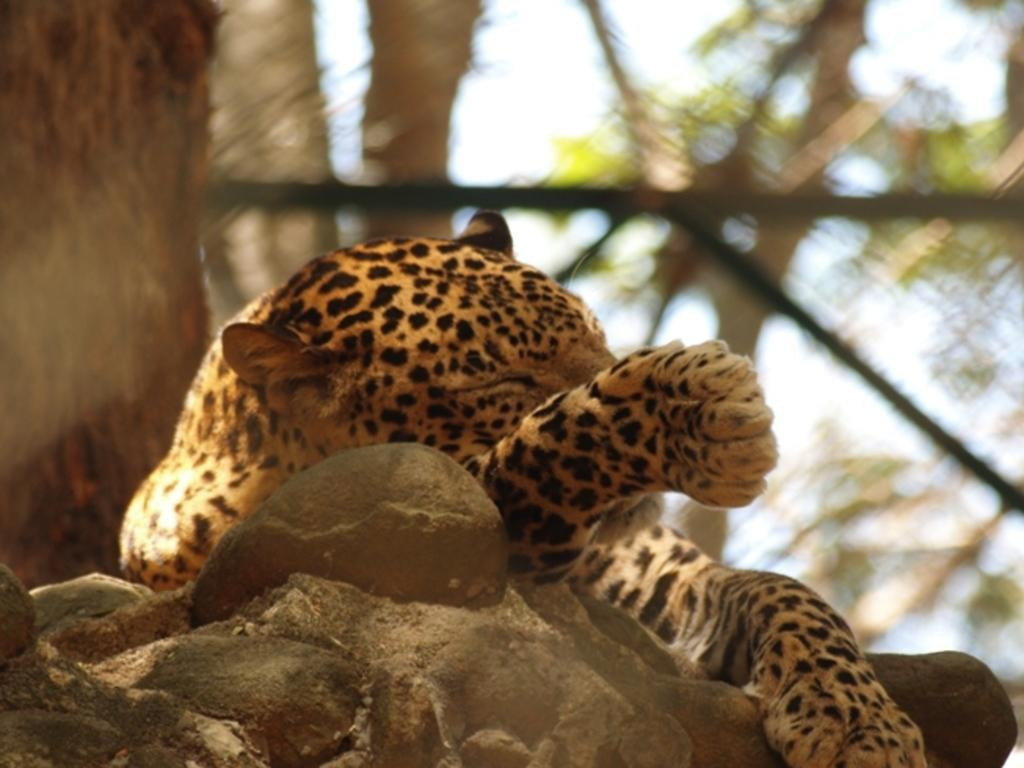What animal is the main subject of the image? There is a leopard in the image. What can be seen in the background of the image? There are trees and other objects in the background of the image. How is the background of the image depicted? The background of the image is blurred. What type of division is being performed by the leopard in the image? There is no division being performed by the leopard in the image; it is an animal and not capable of performing mathematical operations. 